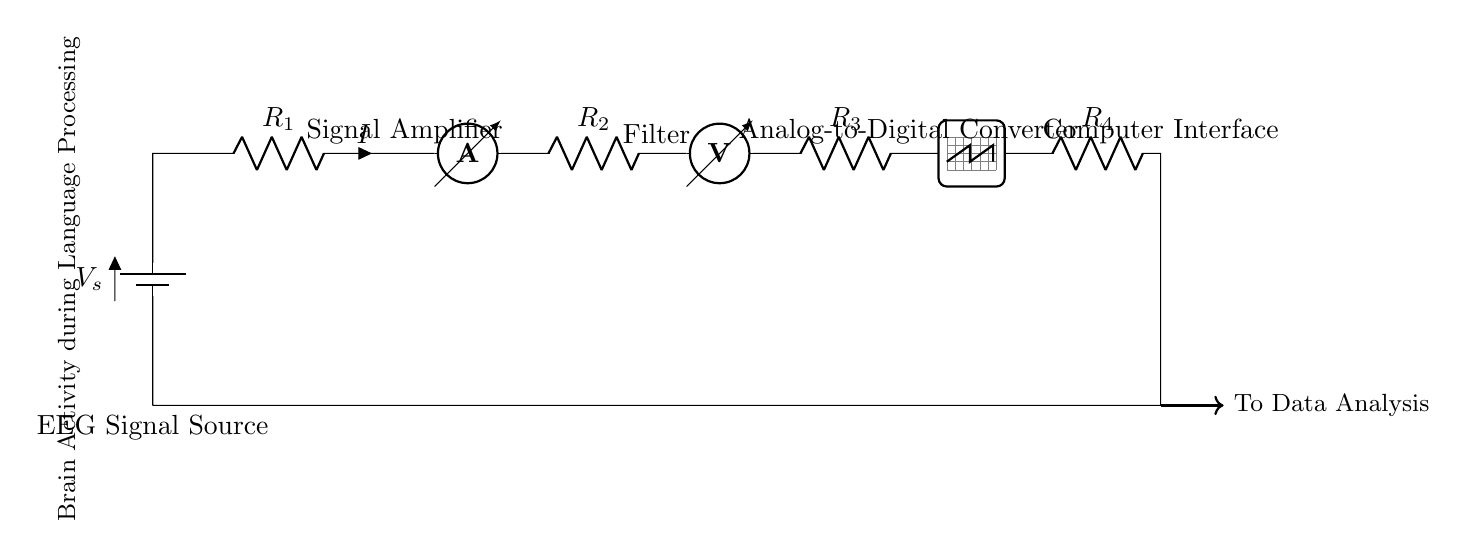What is the source of the EEG signal? The circuit diagram indicates that the source is labeled as "EEG Signal Source," which provides the input signal related to brain activity.
Answer: EEG Signal Source How many resistors are in the circuit? The circuit has four resistors labeled R1, R2, R3, and R4, all placed in series, making a total of four resistive components.
Answer: Four What is the function of the Signal Amplifier? The Signal Amplifier is crucial for increasing the amplitude of the EEG signal, making subsequent processing more effective.
Answer: To amplify the signal What is the purpose of the Analog-to-Digital Converter? The Analog-to-Digital Converter (ADC) serves to convert the amplified analog EEG signals into digital form, which is essential for digital processing and analysis.
Answer: Convert analog to digital If R1 has a resistance of 1 kilo-ohm and R2 has a resistance of 2 kilo-ohms, what would be the total resistance in the circuit? Since all resistors are in series, the total resistance can be found by summing the individual resistances. Therefore, the total resistance is 1 kilo-ohm plus 2 kilo-ohms plus the resistances of R3 and R4 (not specified, but assuming they have values). The answer depends on the values of R3 and R4, which need to be specified for an accurate total. Because the values of R3 and R4 are unknown, the total resistance cannot be definitively calculated.
Answer: Not determinable What is the last component that data is sent to in the circuit? The data from the EEG signal is sent to the "Computer Interface," which implies that it is the final point for processing before analysis.
Answer: Computer Interface 